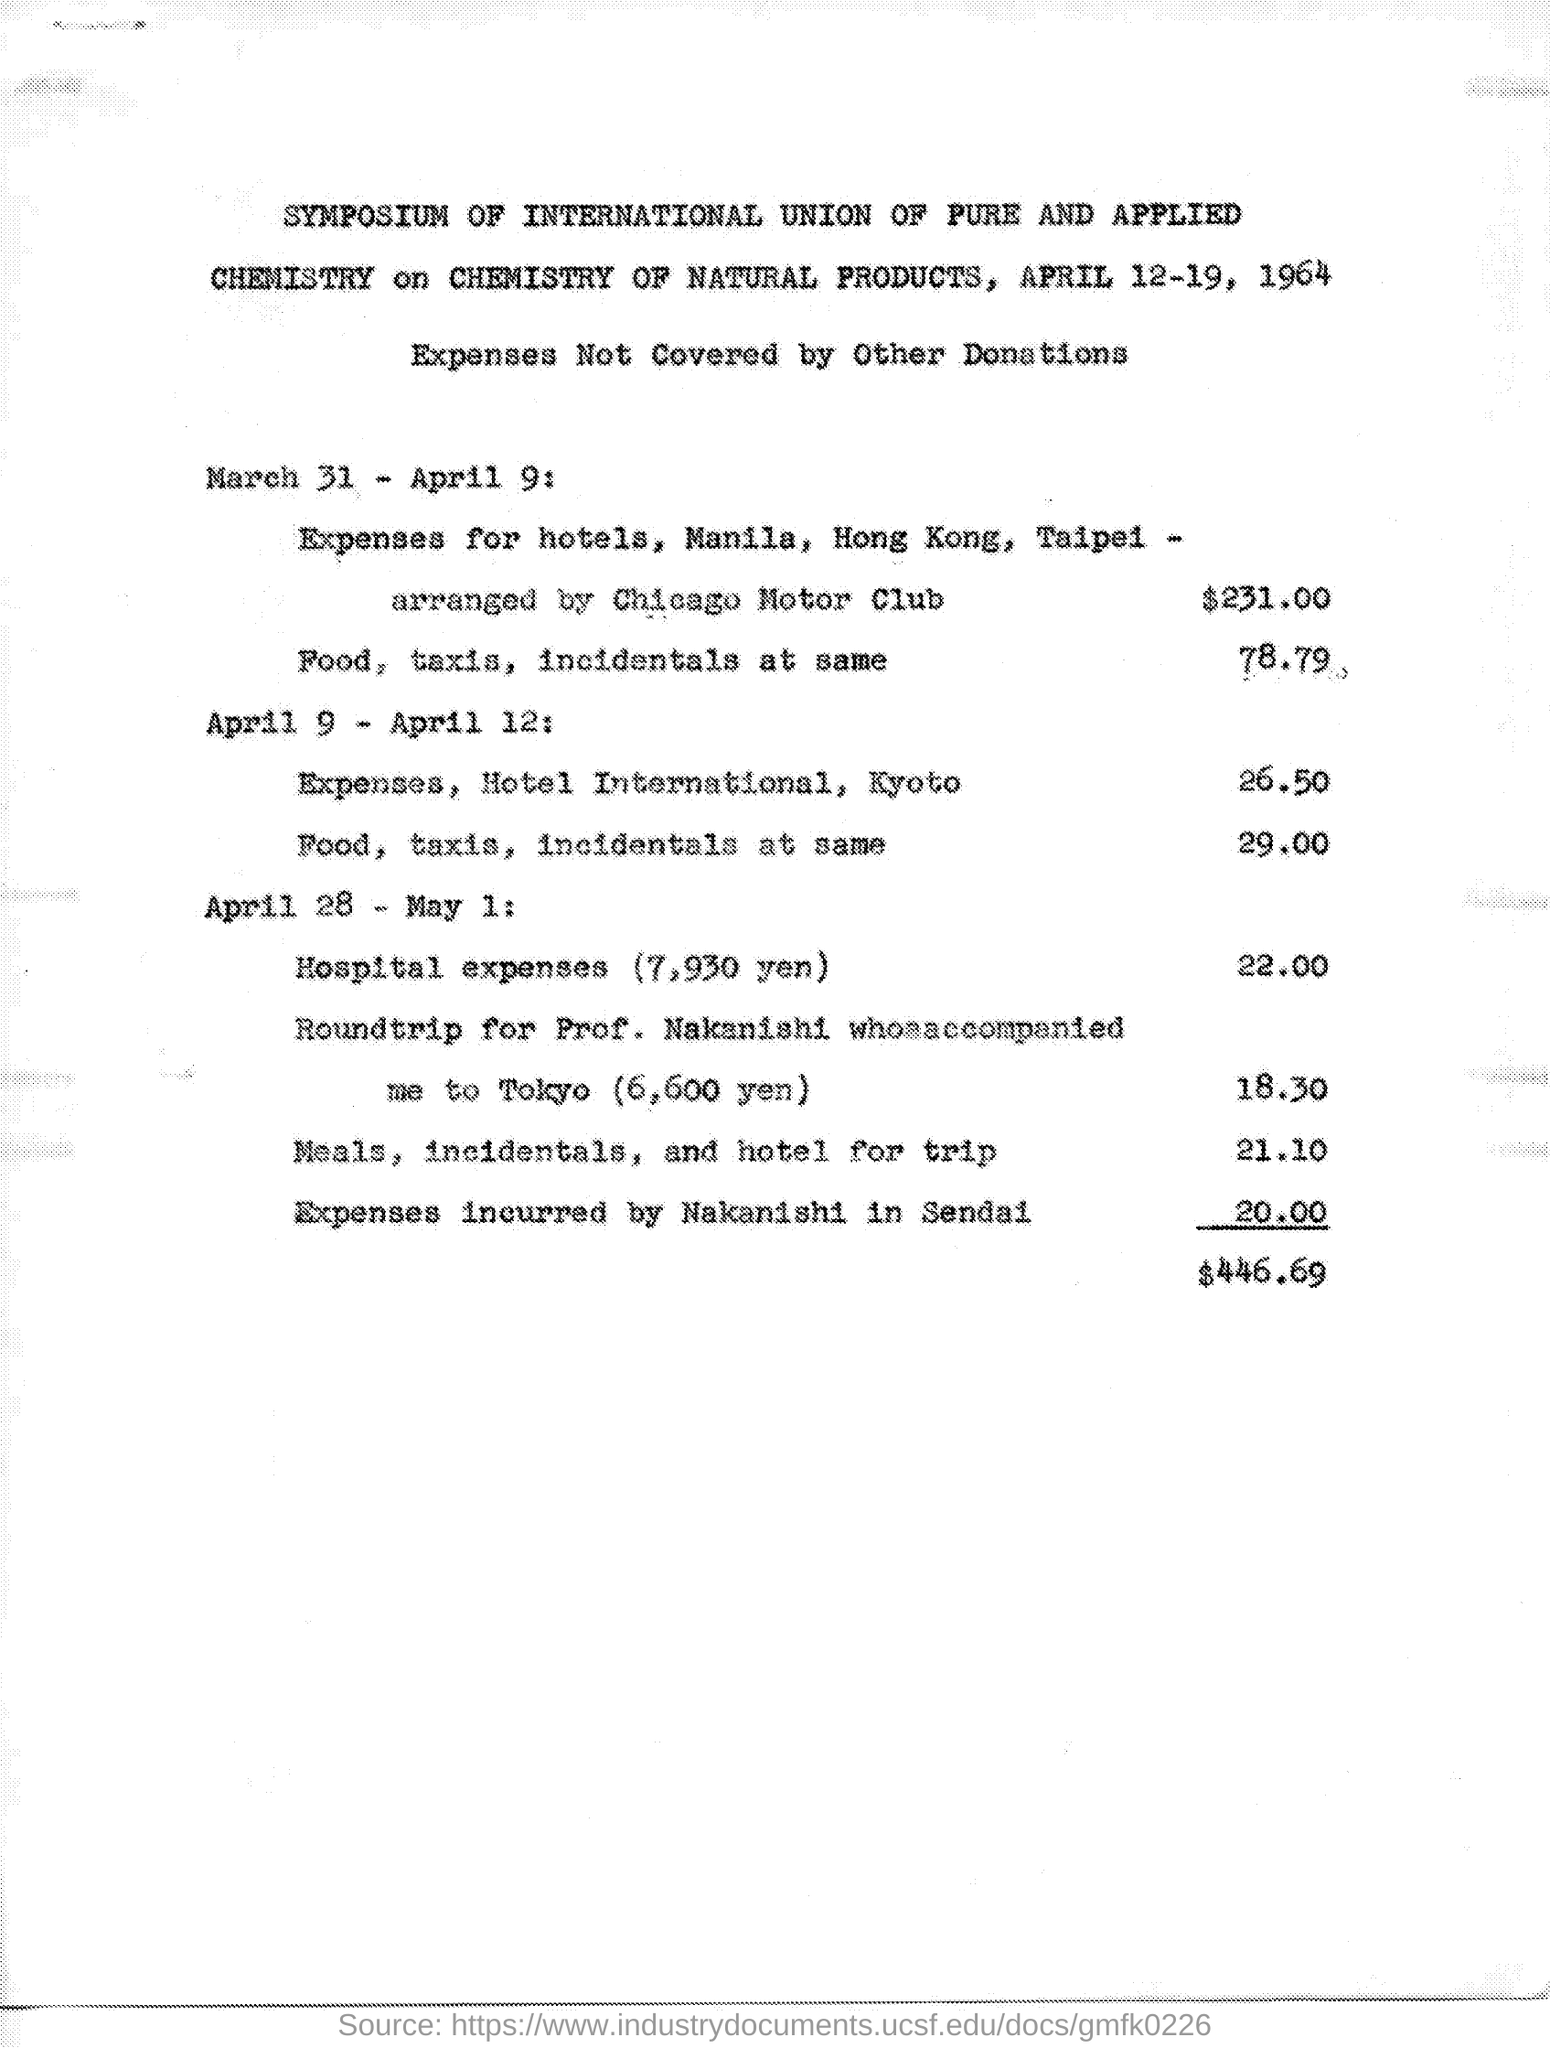Indicate a few pertinent items in this graphic. The symposium is going to be held on April 12-19, 1964. On March 31 to April 9, the amount for food, taxis, and incidentals was $78.79. The total amount at the end is $446.69. 